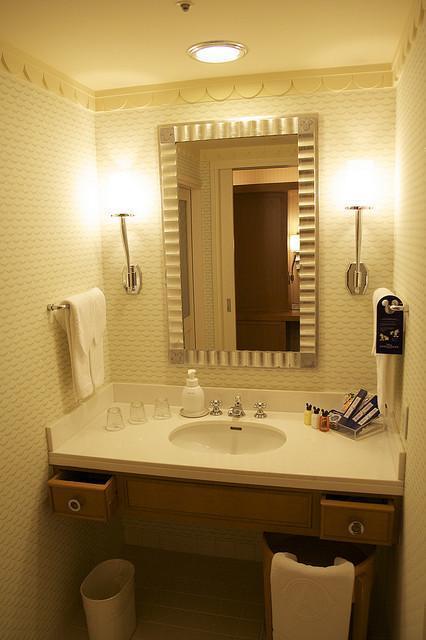How many lamps are on?
Give a very brief answer. 2. 